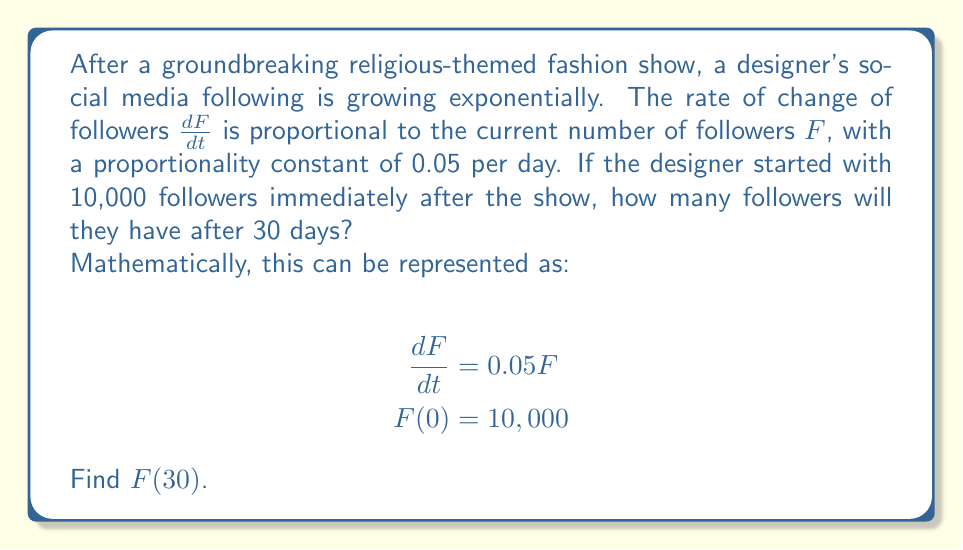Can you solve this math problem? Let's solve this first-order differential equation step by step:

1) We have the differential equation $\frac{dF}{dt} = 0.05F$ with initial condition $F(0) = 10,000$.

2) This is a separable equation. Let's separate the variables:

   $$\frac{dF}{F} = 0.05dt$$

3) Integrate both sides:

   $$\int \frac{dF}{F} = \int 0.05dt$$

4) This gives us:

   $$\ln|F| = 0.05t + C$$

   where $C$ is a constant of integration.

5) Exponentiate both sides:

   $$F = e^{0.05t + C} = e^C \cdot e^{0.05t}$$

6) Let $A = e^C$. Then our general solution is:

   $$F = A \cdot e^{0.05t}$$

7) Use the initial condition $F(0) = 10,000$ to find $A$:

   $$10,000 = A \cdot e^{0.05 \cdot 0} = A$$

8) So our particular solution is:

   $$F = 10,000 \cdot e^{0.05t}$$

9) To find $F(30)$, we substitute $t = 30$:

   $$F(30) = 10,000 \cdot e^{0.05 \cdot 30} = 10,000 \cdot e^{1.5} \approx 44,817$$
Answer: 44,817 followers 